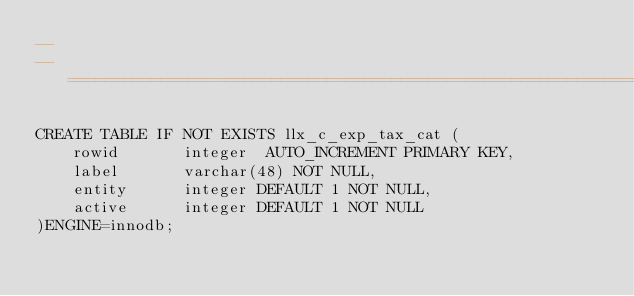<code> <loc_0><loc_0><loc_500><loc_500><_SQL_>--
-- ============================================================================

CREATE TABLE IF NOT EXISTS llx_c_exp_tax_cat (
    rowid       integer  AUTO_INCREMENT PRIMARY KEY,
    label       varchar(48) NOT NULL, 
    entity      integer DEFAULT 1 NOT NULL,
    active      integer DEFAULT 1 NOT NULL	          
)ENGINE=innodb;</code> 